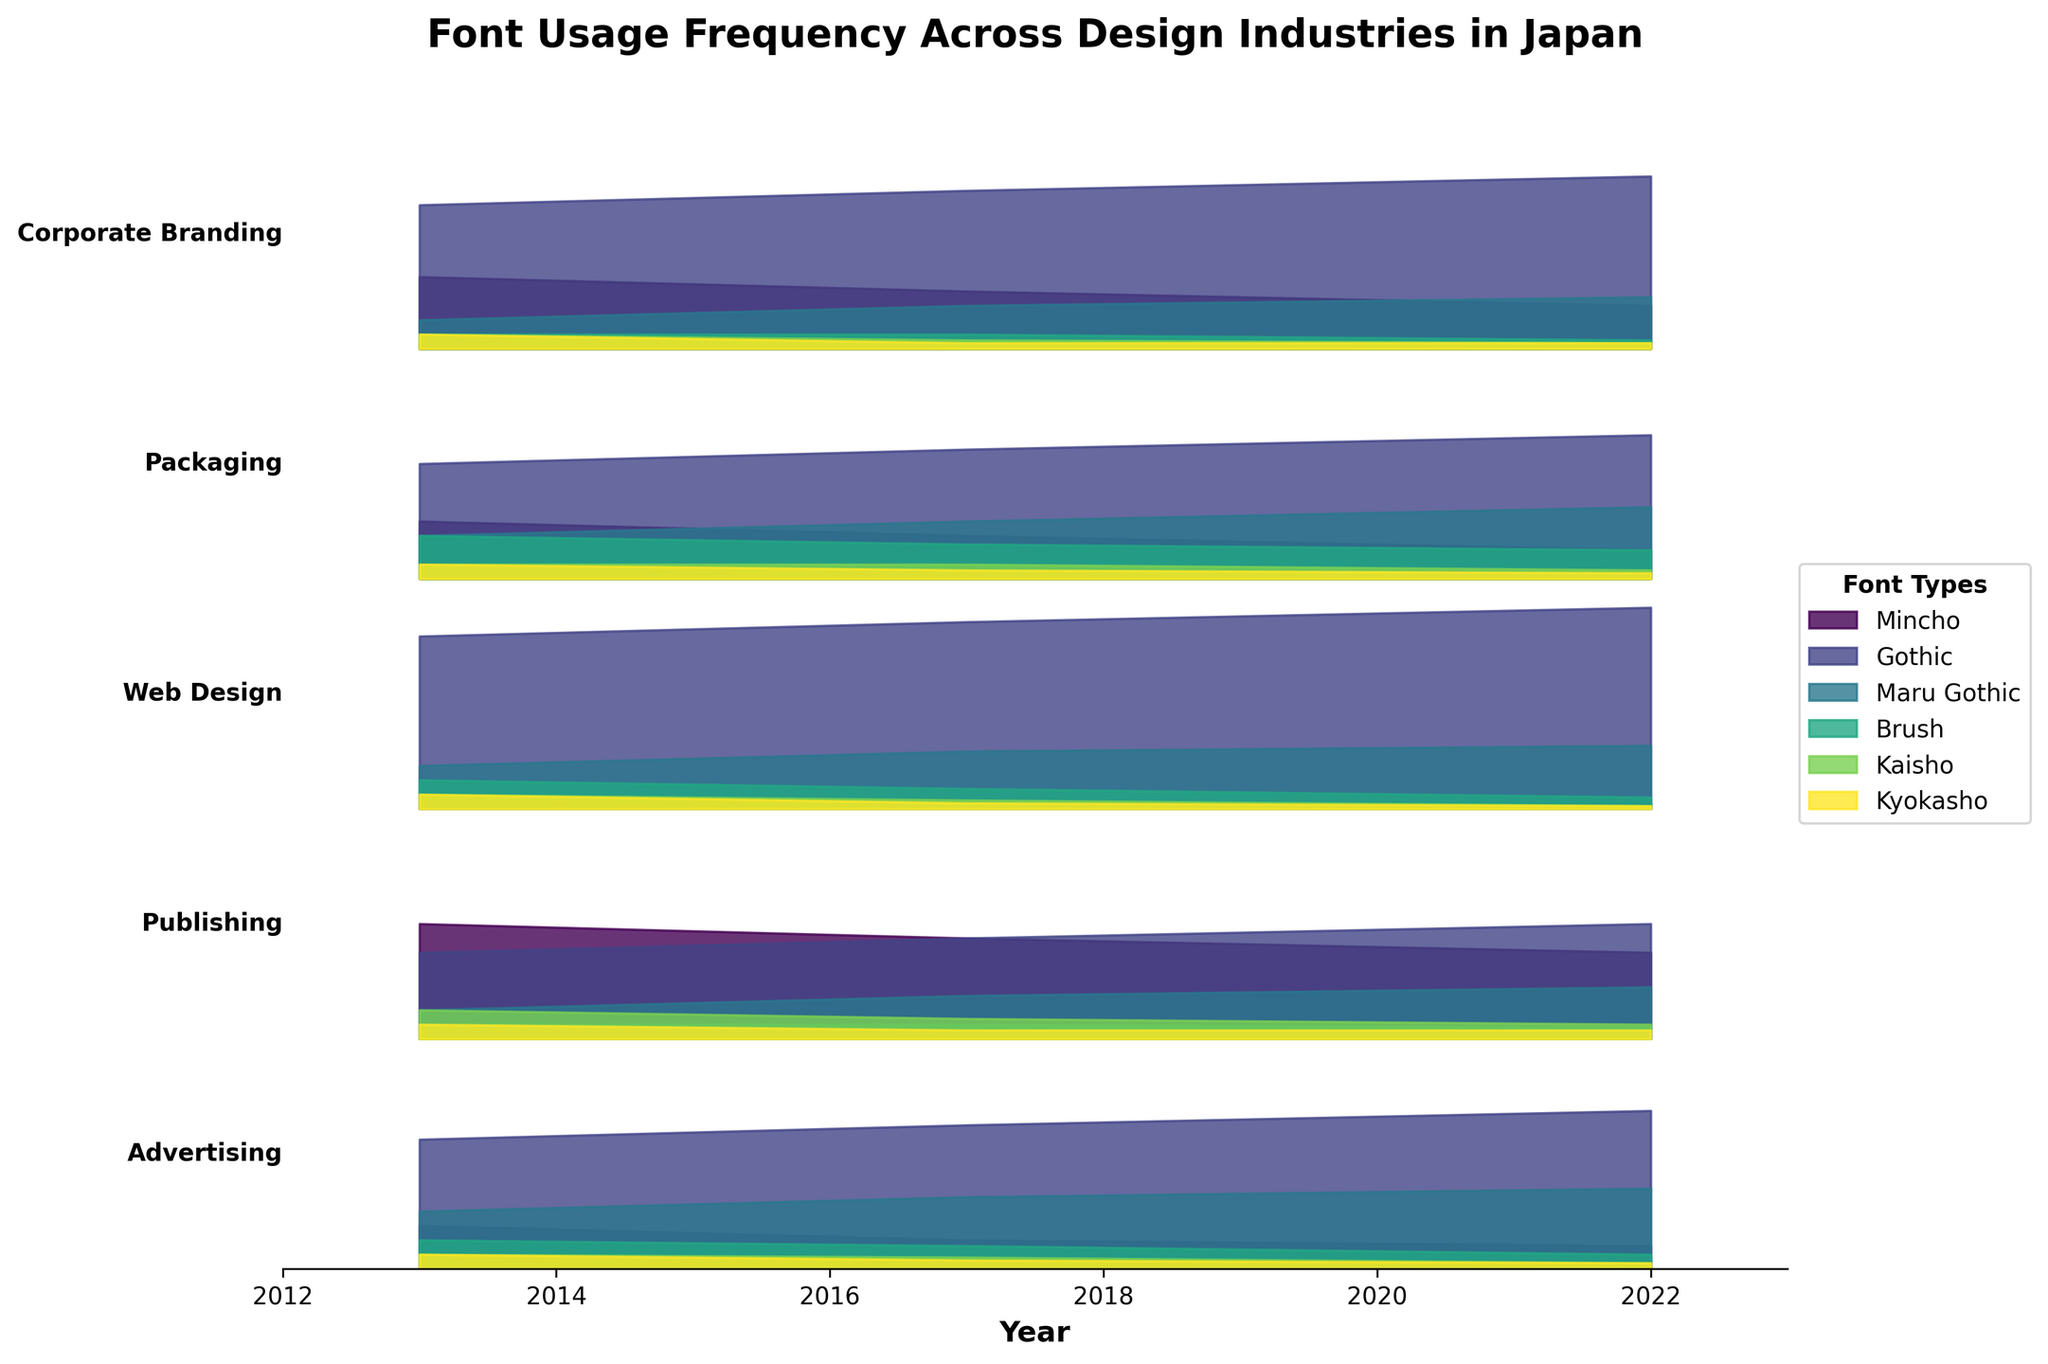What is the title of the plot? The title is located at the top of the figure and describes its content.
Answer: Font Usage Frequency Across Design Industries in Japan Which industry shows the highest usage of Mincho font in 2013? Look at the 2013 data and compare Mincho font usage among industries.
Answer: Publishing How has the usage of the Gothic font in Advertising changed over the decade? Observe the changes in Gothic font usage for Advertising from 2013 to 2022.
Answer: Increased from 45% to 55% What are the two main fonts used in Web Design in 2022? Identify the fonts with the largest fill areas for Web Design in 2022.
Answer: Gothic and Maru Gothic Which industry had the most significant decrease in Mincho usage from 2013 to 2022? Calculate the difference in Mincho usage for each industry between 2013 and 2022, and find the largest decrease.
Answer: Publishing Compare the usage of Maru Gothic font in Packaging and Corporate Branding in 2022. Look at the width of the fill areas for the Maru Gothic font in Packaging and Corporate Branding for 2022.
Answer: Packaging has higher usage (25% vs. 18%) Which font shows a consistent overall increase in usage across all industries from 2013 to 2022? Examine the overall trend for each font type across different industries over the years.
Answer: Gothic What is the least used font in Corporate Branding in 2022? Find the smallest fill area for Corporate Branding in 2022.
Answer: Brush In which year did Web Design have the highest usage of the Brush font? Compare the Brush font usage in Web Design for the given years.
Answer: 2013 What is the average usage of the Kyokasho font in Publishing across the provided years? Sum the Kyokasho usage in Publishing for 2013, 2017, and 2022, then divide by 3.
Answer: (5 + 3 + 3)/3 = 3.7 